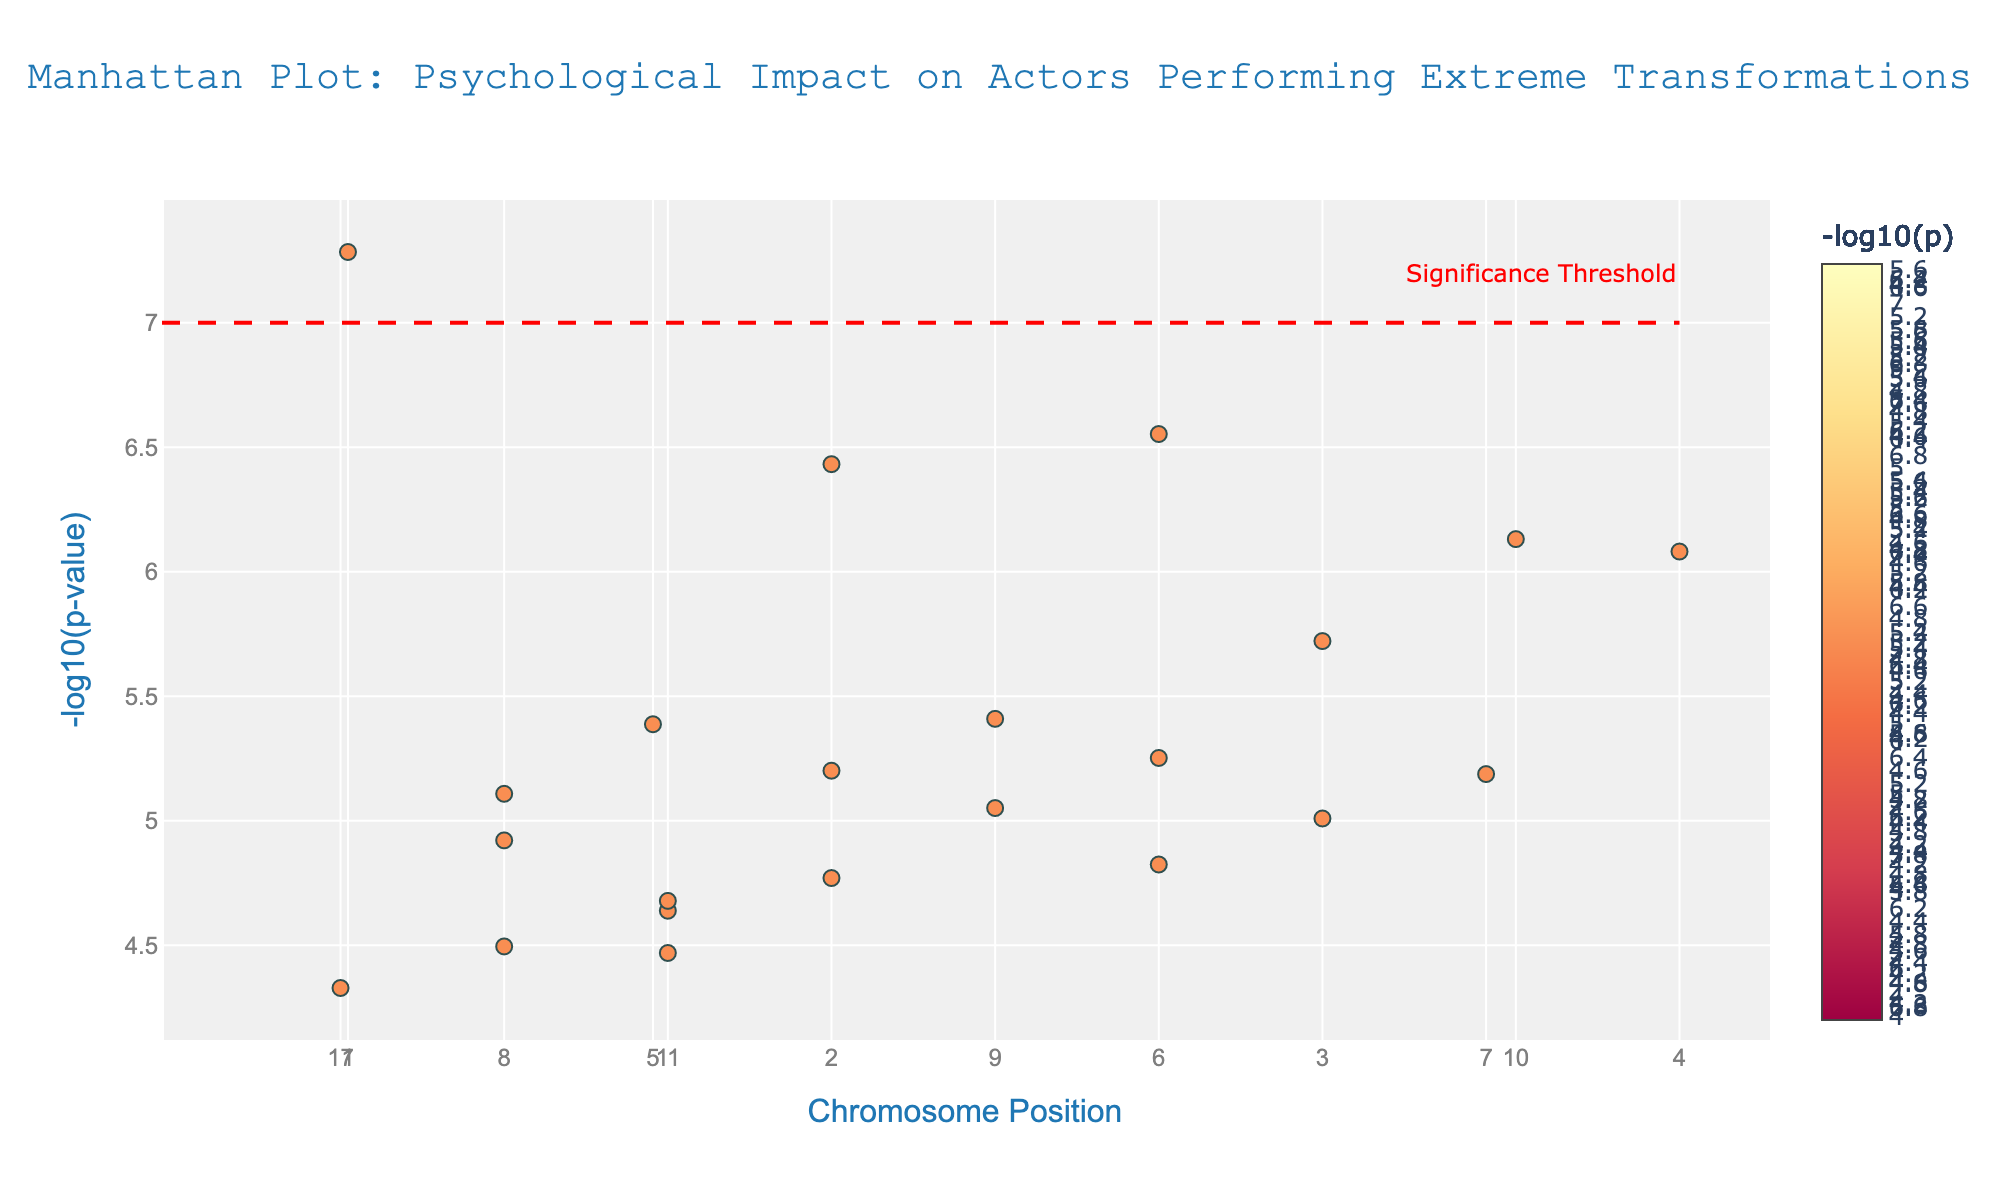What is the title of the plot? The title can be found at the top of the plot. It reads, "Manhattan Plot: Psychological Impact on Actors Performing Extreme Transformations".
Answer: Manhattan Plot: Psychological Impact on Actors Performing Extreme Transformations What are the axes labels on the plot? The x-axis is labeled "Chromosome Position" and the y-axis is labeled "-log10(p-value)". These can be found along the respective axes.
Answer: Chromosome Position; -log10(p-value) Which gene has the smallest p-value in the data? The smallest p-value corresponds to the highest point on the plot. This highest point is identified by hovering over it, revealing it belongs to the gene COMT on chromosome 1.
Answer: COMT How many data points have p-values below the significance threshold? Data points below the significance threshold are above the red dashed line (y=7). Count the data points that are above this line on the plot.
Answer: 5 data points Which chromosomes have more than one gene associated with them on the plot? Look at the legend and hover over the data points to identify chromosomes with multiple genes. Chromosomes 5 and 11, for instance, have more than one gene on the plot.
Answer: Chromosomes 5 and 11 Compare the p-values of genes FKBP5 on Chromosome 3 and SLC6A4 on Chromosome 5. Which one has a smaller p-value? By comparing the height of the points for FKBP5 and SLC6A4, FKBP5 is higher. A higher point corresponds to a smaller p-value.
Answer: FKBP5 For gene CRHR1, compare the p-values on Chromosomes 4 and 20, which position indicates a lower p-value? Compare the heights of the points for CRHR1 on Chromosomes 4 and 20, the higher point is on Chromosome 4, indicating a lower p-value.
Answer: Chromosome 4 Identify the gene associated with the highest p-value in the data. The lowest point on the plot represents the highest p-value. Hovering over this point shows the gene NR3C1 on Chromosome 12.
Answer: NR3C1 What is the average -log10(p-value) for genes identified on Chromosome 10? Locate the points on Chromosome 10, there is only one point for gene CACNA1C. The average -log10(p-value) is the value of this single point.
Answer: value of CACNA1C Which data point corresponding to OXTR gene has a smaller p-value: Chromosome 6 or Chromosome 22? Compare the heights of the points for OXTR on Chromosome 6 and Chromosome 22. Higher points signify smaller p-values.
Answer: Chromosome 6 